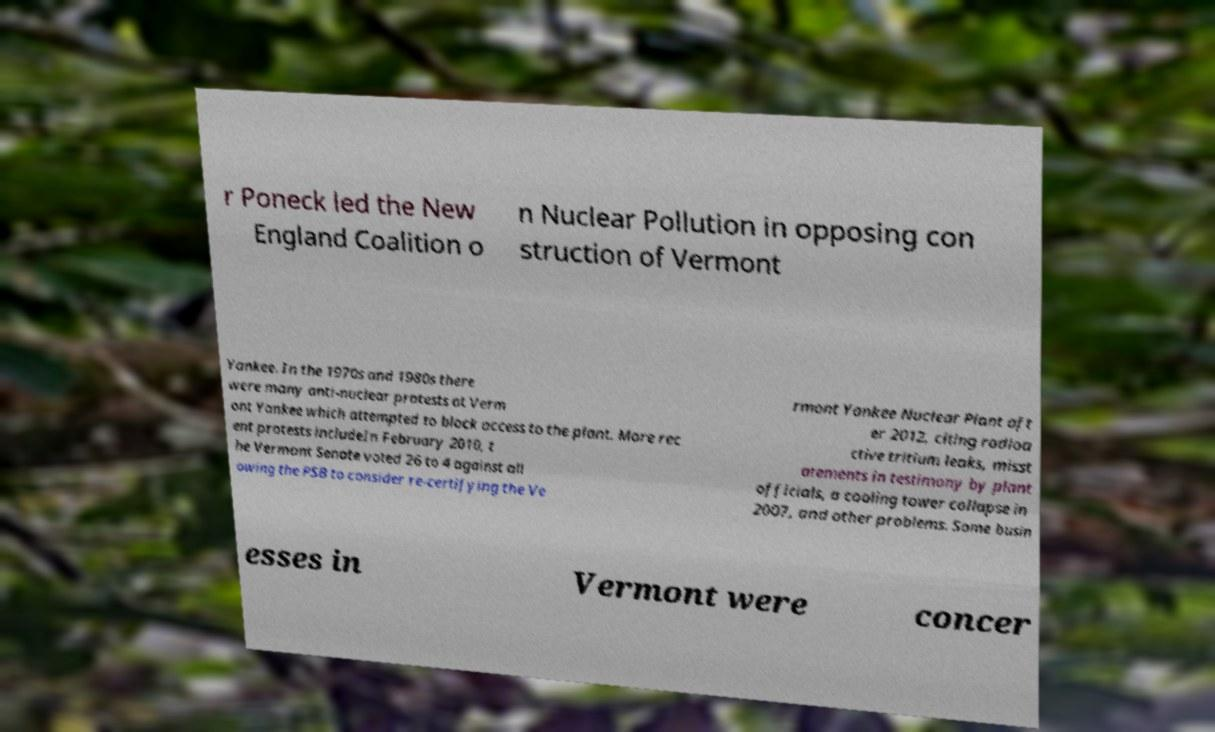Please read and relay the text visible in this image. What does it say? r Poneck led the New England Coalition o n Nuclear Pollution in opposing con struction of Vermont Yankee. In the 1970s and 1980s there were many anti-nuclear protests at Verm ont Yankee which attempted to block access to the plant. More rec ent protests includeIn February 2010, t he Vermont Senate voted 26 to 4 against all owing the PSB to consider re-certifying the Ve rmont Yankee Nuclear Plant aft er 2012, citing radioa ctive tritium leaks, misst atements in testimony by plant officials, a cooling tower collapse in 2007, and other problems. Some busin esses in Vermont were concer 